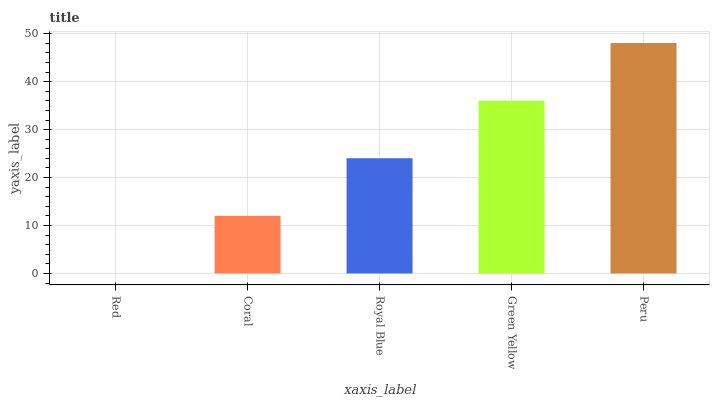Is Red the minimum?
Answer yes or no. Yes. Is Peru the maximum?
Answer yes or no. Yes. Is Coral the minimum?
Answer yes or no. No. Is Coral the maximum?
Answer yes or no. No. Is Coral greater than Red?
Answer yes or no. Yes. Is Red less than Coral?
Answer yes or no. Yes. Is Red greater than Coral?
Answer yes or no. No. Is Coral less than Red?
Answer yes or no. No. Is Royal Blue the high median?
Answer yes or no. Yes. Is Royal Blue the low median?
Answer yes or no. Yes. Is Peru the high median?
Answer yes or no. No. Is Red the low median?
Answer yes or no. No. 